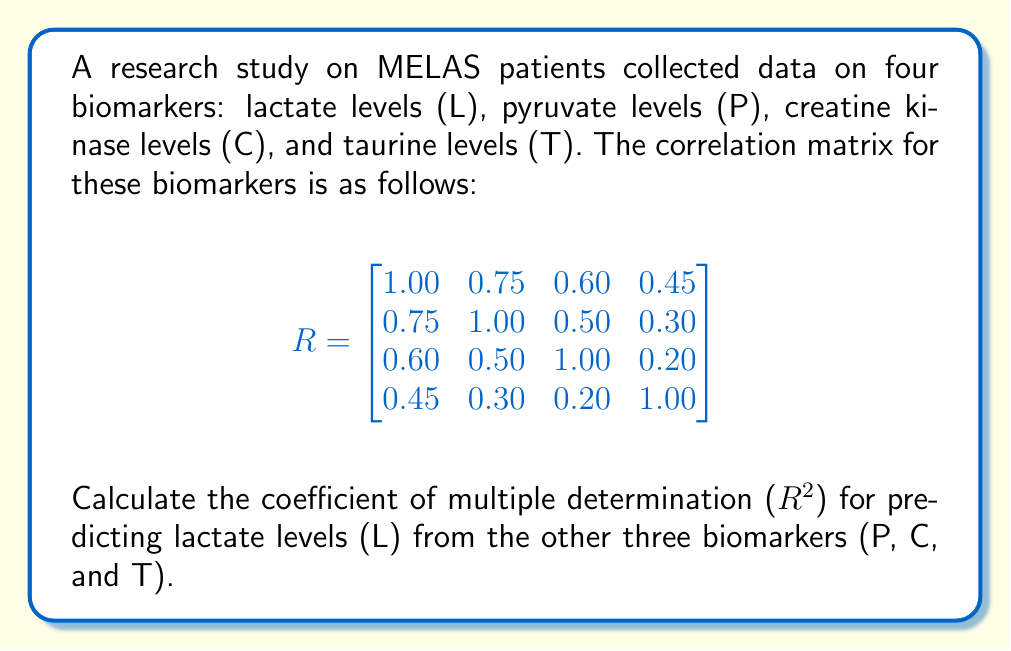Give your solution to this math problem. To calculate the coefficient of multiple determination ($R^2$), we'll use the following steps:

1) The coefficient of multiple determination is given by the formula:

   $$R^2 = 1 - \frac{|R_{yy.x}|}{|R_{yy}|}$$

   where $|R_{yy.x}|$ is the determinant of the partial correlation matrix, and $|R_{yy}|$ is the variance of the dependent variable (which is 1 in a correlation matrix).

2) To find $|R_{yy.x}|$, we need to calculate the inverse of the predictor variables' correlation matrix and use it to compute the partial correlation:

   $$R_{xx} = \begin{bmatrix}
   1.00 & 0.50 & 0.30 \\
   0.50 & 1.00 & 0.20 \\
   0.30 & 0.20 & 1.00
   \end{bmatrix}$$

3) Calculate the inverse of $R_{xx}$:

   $$R_{xx}^{-1} = \begin{bmatrix}
   1.3889 & -0.6944 & -0.2778 \\
   -0.6944 & 1.2500 & -0.0833 \\
   -0.2778 & -0.0833 & 1.0972
   \end{bmatrix}$$

4) Calculate the vector of correlations between the dependent variable (L) and the predictors:

   $$r_{yx} = \begin{bmatrix} 0.75 \\ 0.60 \\ 0.45 \end{bmatrix}$$

5) Compute $R_{yy.x}$:

   $$R_{yy.x} = 1 - r_{yx}^T R_{xx}^{-1} r_{yx}$$

6) Perform the matrix multiplication:

   $$R_{yy.x} = 1 - [0.75 \quad 0.60 \quad 0.45] \begin{bmatrix}
   1.3889 & -0.6944 & -0.2778 \\
   -0.6944 & 1.2500 & -0.0833 \\
   -0.2778 & -0.0833 & 1.0972
   \end{bmatrix} \begin{bmatrix} 0.75 \\ 0.60 \\ 0.45 \end{bmatrix}$$

7) Simplify:

   $$R_{yy.x} = 1 - 0.6094 = 0.3906$$

8) Calculate $R^2$:

   $$R^2 = 1 - \frac{|R_{yy.x}|}{|R_{yy}|} = 1 - \frac{0.3906}{1} = 0.6094$$

Therefore, the coefficient of multiple determination ($R^2$) for predicting lactate levels from pyruvate, creatine kinase, and taurine levels is 0.6094.
Answer: $R^2 = 0.6094$ 